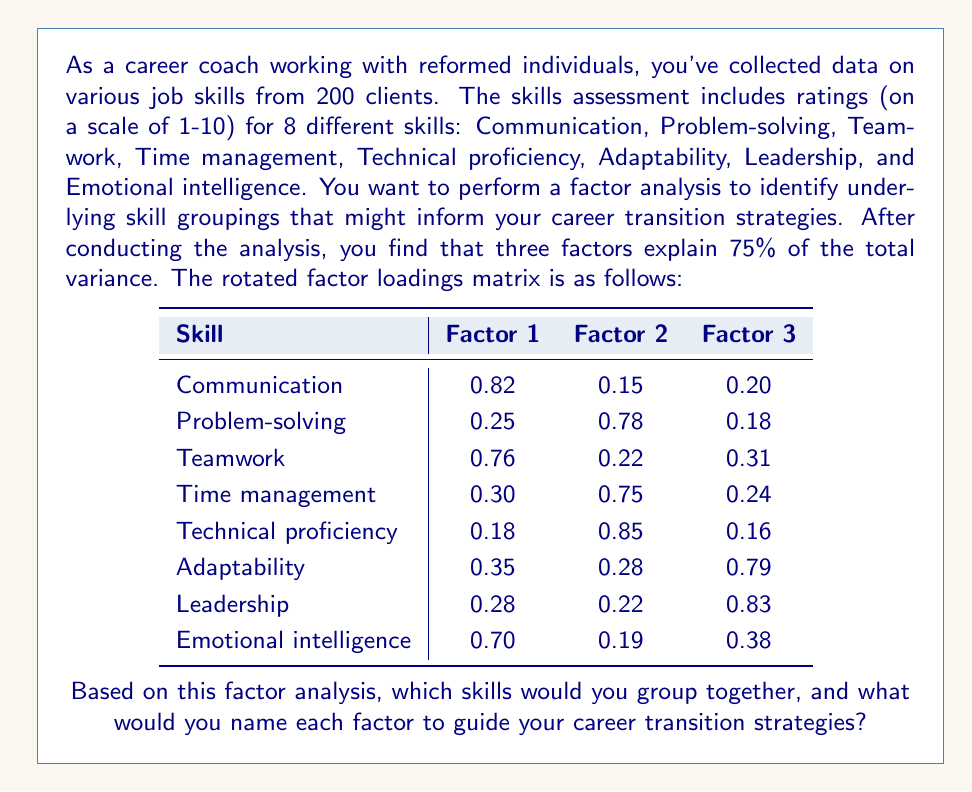Help me with this question. To interpret the factor analysis results and group the skills, we need to examine the factor loadings for each skill across the three factors. Generally, we consider loadings above 0.6 or 0.7 to be significant.

Let's analyze each factor:

1. Factor 1:
   - Communication (0.82)
   - Teamwork (0.76)
   - Emotional intelligence (0.70)

   These skills all relate to interpersonal abilities and how one interacts with others. We could call this factor "Interpersonal Skills" or "Social Competence."

2. Factor 2:
   - Problem-solving (0.78)
   - Time management (0.75)
   - Technical proficiency (0.85)

   These skills are more related to task execution and cognitive abilities. We could name this factor "Task-Oriented Skills" or "Cognitive Competence."

3. Factor 3:
   - Adaptability (0.79)
   - Leadership (0.83)

   These skills relate to managing change and guiding others. We could call this factor "Leadership and Adaptability" or "Change Management Skills."

By grouping the skills this way, we can identify three key areas of competence that are important for career transitions:

1. Interpersonal Skills (Factor 1): Essential for roles requiring strong communication and teamwork.
2. Task-Oriented Skills (Factor 2): Important for positions that require problem-solving, time management, and technical abilities.
3. Leadership and Adaptability Skills (Factor 3): Crucial for roles involving management, leadership, or working in dynamic environments.

This grouping can help guide career transition strategies by identifying which skill sets a client is strongest in and which areas may need development based on their desired career path.
Answer: The skills can be grouped into three factors:

1. Interpersonal Skills (Factor 1): Communication, Teamwork, Emotional intelligence
2. Task-Oriented Skills (Factor 2): Problem-solving, Time management, Technical proficiency
3. Leadership and Adaptability Skills (Factor 3): Adaptability, Leadership

These groupings can be used to guide career transition strategies by focusing on developing and leveraging skills within each factor based on the requirements of potential career paths. 